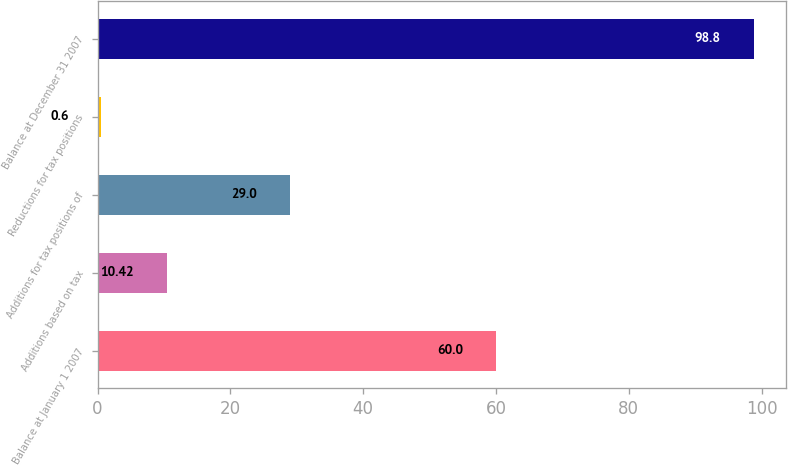<chart> <loc_0><loc_0><loc_500><loc_500><bar_chart><fcel>Balance at January 1 2007<fcel>Additions based on tax<fcel>Additions for tax positions of<fcel>Reductions for tax positions<fcel>Balance at December 31 2007<nl><fcel>60<fcel>10.42<fcel>29<fcel>0.6<fcel>98.8<nl></chart> 